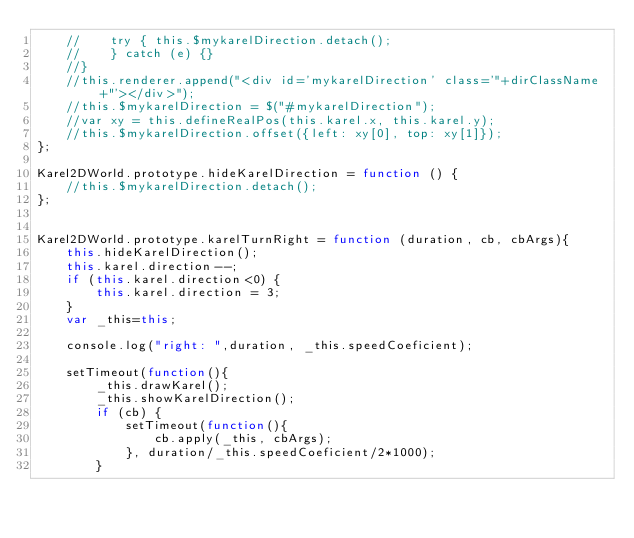Convert code to text. <code><loc_0><loc_0><loc_500><loc_500><_JavaScript_>    //    try { this.$mykarelDirection.detach();
    //    } catch (e) {}
    //}
    //this.renderer.append("<div id='mykarelDirection' class='"+dirClassName+"'></div>");
    //this.$mykarelDirection = $("#mykarelDirection");
    //var xy = this.defineRealPos(this.karel.x, this.karel.y);
    //this.$mykarelDirection.offset({left: xy[0], top: xy[1]});
};

Karel2DWorld.prototype.hideKarelDirection = function () {
    //this.$mykarelDirection.detach();
};


Karel2DWorld.prototype.karelTurnRight = function (duration, cb, cbArgs){
    this.hideKarelDirection();
    this.karel.direction--;
    if (this.karel.direction<0) {
        this.karel.direction = 3;
    }
    var _this=this;

    console.log("right: ",duration, _this.speedCoeficient);

    setTimeout(function(){
        _this.drawKarel();
        _this.showKarelDirection();
        if (cb) {
            setTimeout(function(){
                cb.apply(_this, cbArgs);
            }, duration/_this.speedCoeficient/2*1000);
        }</code> 